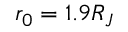<formula> <loc_0><loc_0><loc_500><loc_500>r _ { 0 } = 1 . 9 R _ { J }</formula> 